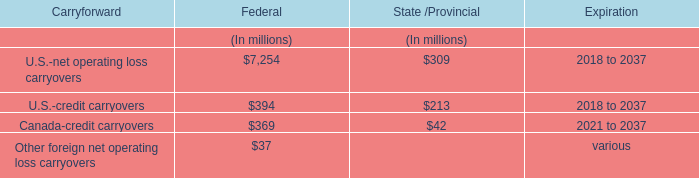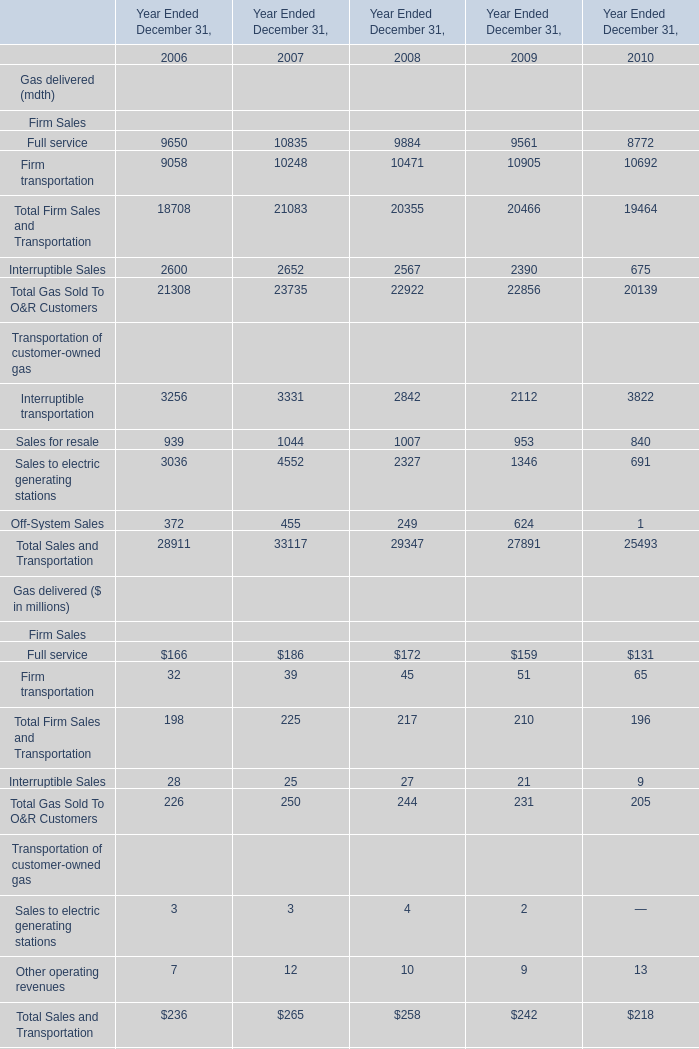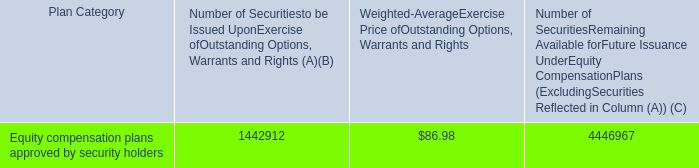What is the sum of Other operating revenues in 2010 and U.S.-credit carryovers for Federal? (in million) 
Computations: (13 + 394)
Answer: 407.0. 